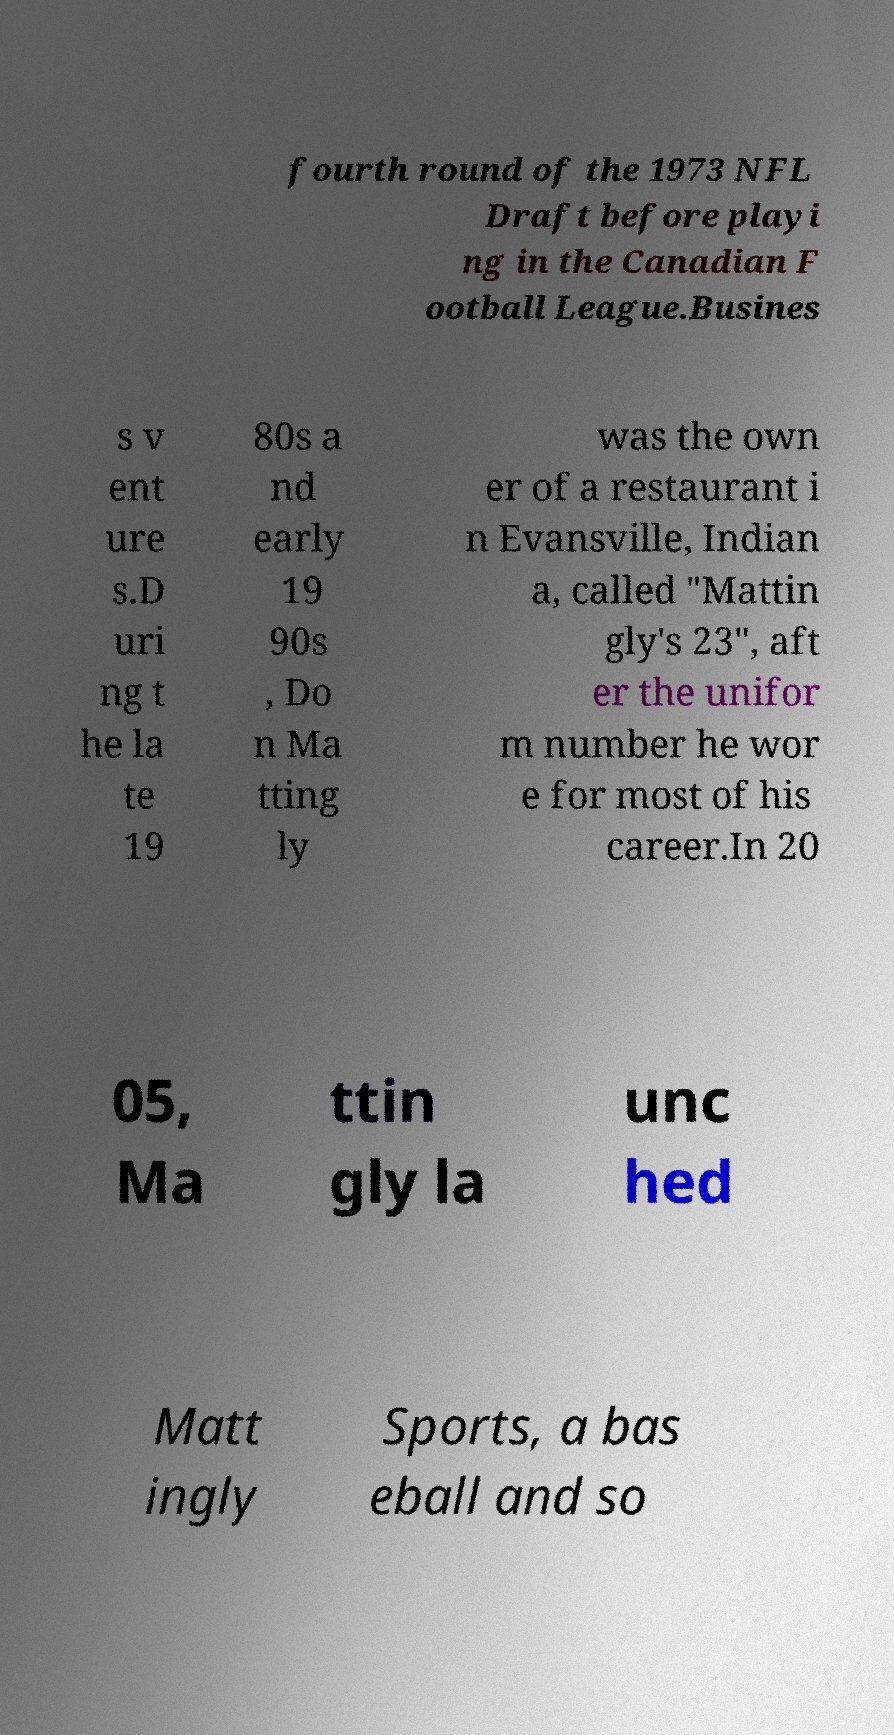Can you read and provide the text displayed in the image?This photo seems to have some interesting text. Can you extract and type it out for me? fourth round of the 1973 NFL Draft before playi ng in the Canadian F ootball League.Busines s v ent ure s.D uri ng t he la te 19 80s a nd early 19 90s , Do n Ma tting ly was the own er of a restaurant i n Evansville, Indian a, called "Mattin gly's 23", aft er the unifor m number he wor e for most of his career.In 20 05, Ma ttin gly la unc hed Matt ingly Sports, a bas eball and so 